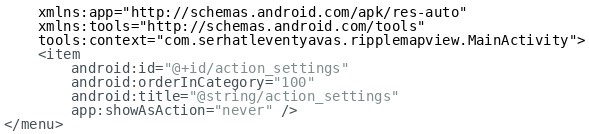Convert code to text. <code><loc_0><loc_0><loc_500><loc_500><_XML_>    xmlns:app="http://schemas.android.com/apk/res-auto"
    xmlns:tools="http://schemas.android.com/tools"
    tools:context="com.serhatleventyavas.ripplemapview.MainActivity">
    <item
        android:id="@+id/action_settings"
        android:orderInCategory="100"
        android:title="@string/action_settings"
        app:showAsAction="never" />
</menu>
</code> 